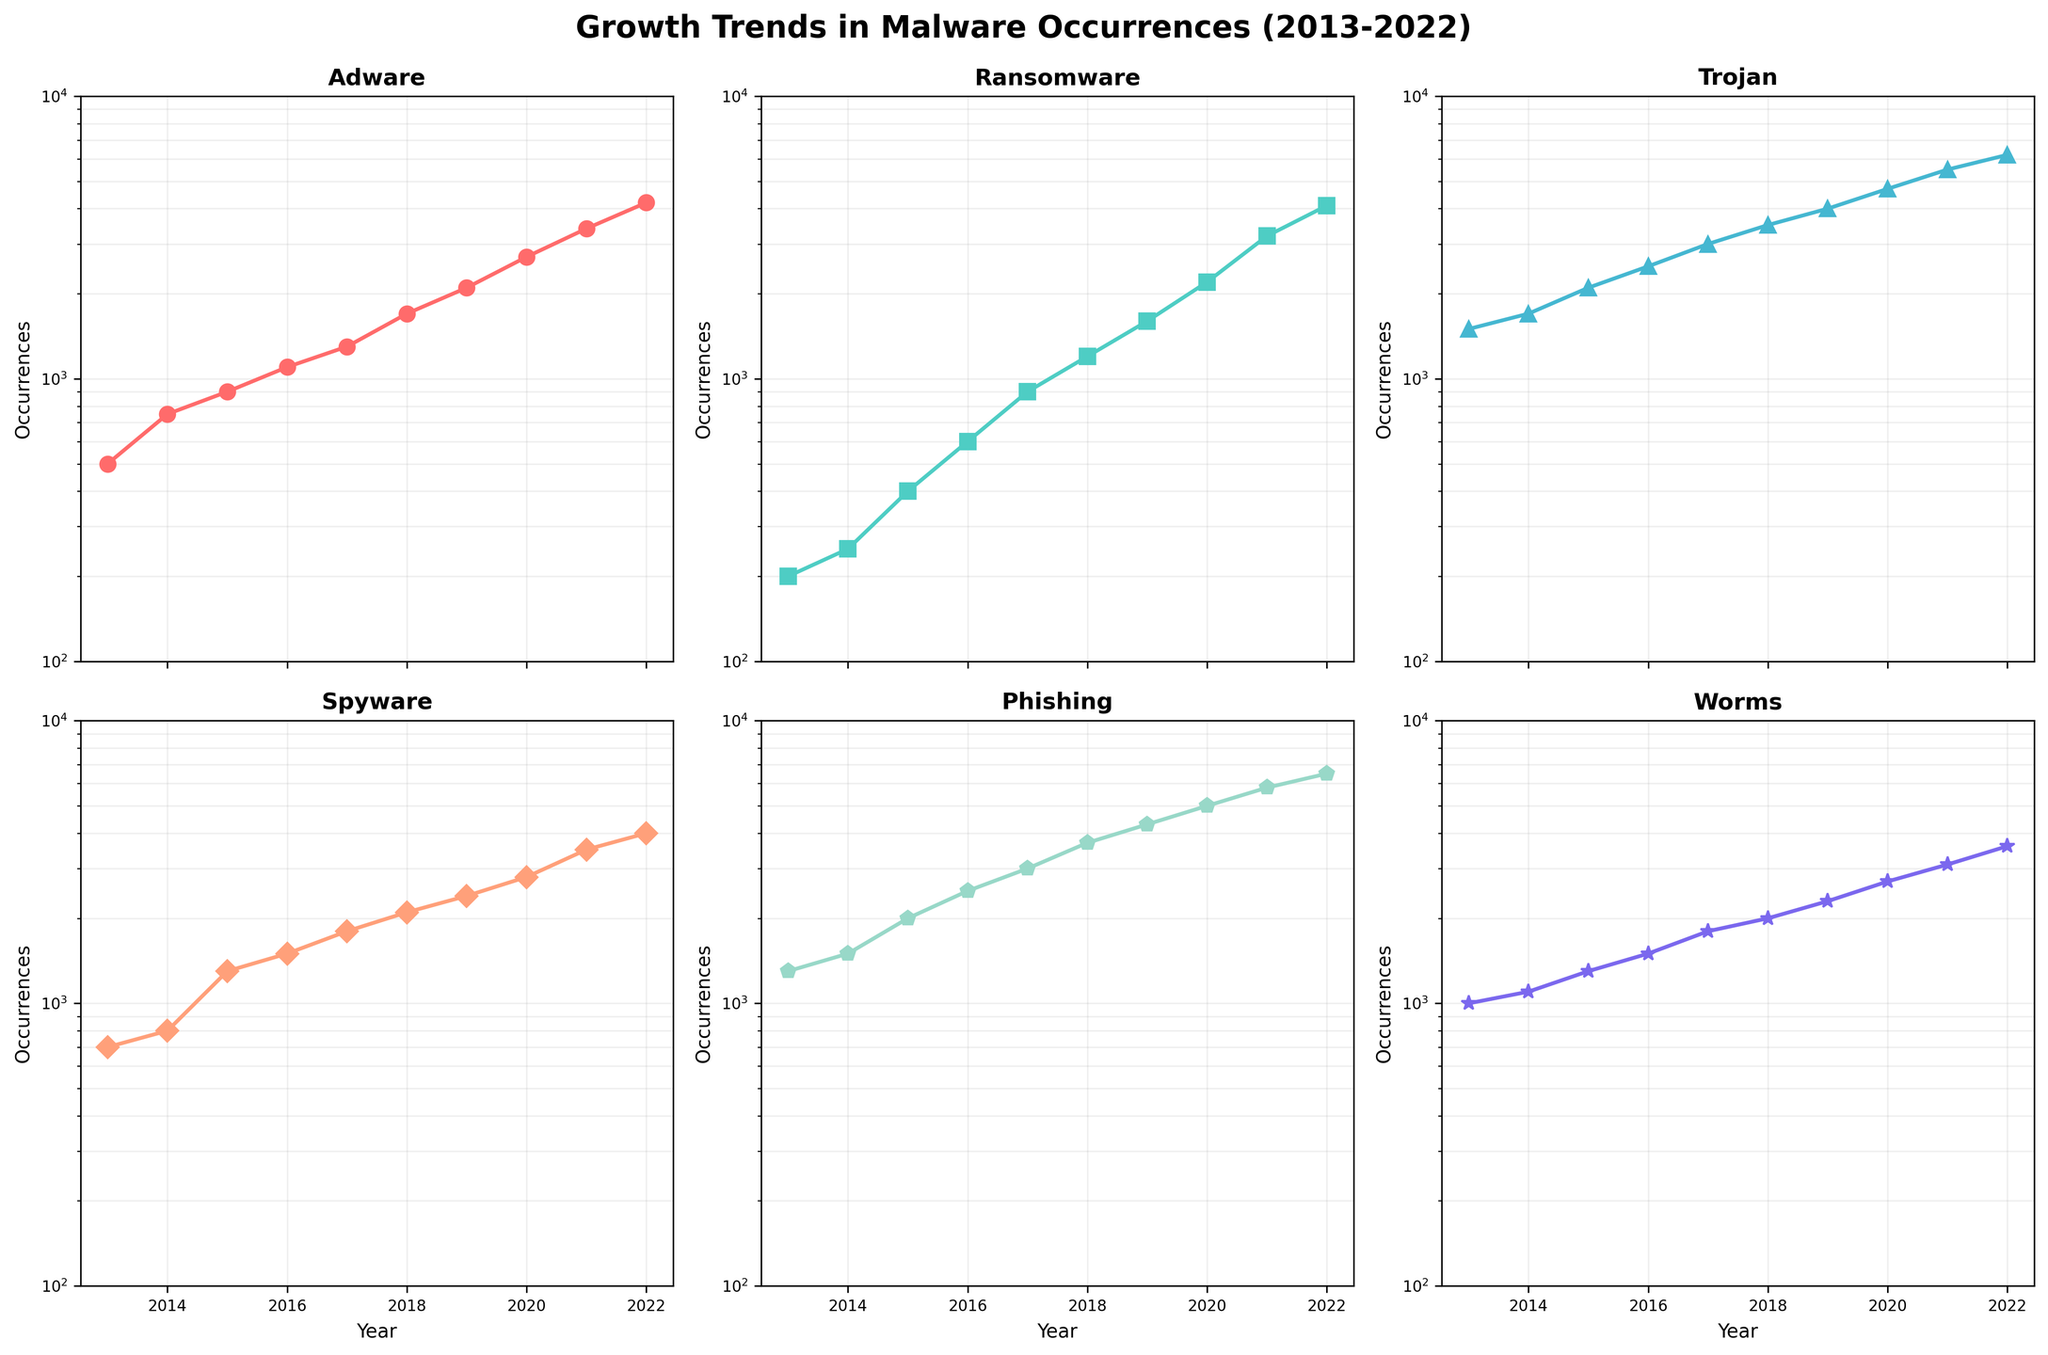Which type of malware had the least occurrences in 2013? By examining the lowest data point in 2013 across all subplots, we find that Ransomware had the smallest occurrences with 200.
Answer: Ransomware What is the overall trend of Phishing occurrences from 2013 to 2022? By analyzing the subplot for Phishing, we can see a consistent increase in occurrences over the years, indicating an upward trend.
Answer: Increasing How many years did Trojan have more than 4000 occurrences? By locating the data points for Trojan and counting the number of years with values above 4000, we see it happened in 3 years (2019, 2021, 2022).
Answer: 3 years Which malware had the largest growth between 2013 and 2022? Calculating the difference between 2022 and 2013 for each malware type, we see that Phishing grew the most (6500-1300=5200).
Answer: Phishing What is the rate of increase for Adware from 2016 to 2017? The Adware data points are 1100 (2016) and 1300 (2017). The rate of increase = \((1300 - 1100) / 1100 \cdot 100\% = 18.18\%\).
Answer: 18.18% Which type of malware had the most occurrences in 2020? Comparing the 2020 data points, Phishing had the highest occurrences with 5000.
Answer: Phishing Did any type of malware have an exponential growth pattern? Observing the log-scale subplots, the growth patterns of all malware types appear relatively linear on a log scale, indicating exponential growth.
Answer: Yes Between Spyware and Worms, which had fewer occurrences in 2018? By checking the 2018 data points, we see that Worms had 2000 occurrences, whereas Spyware had 2100 occurrences.
Answer: Worms What's the approximate average number of Ransomware occurrences over the decade? Adding the Ransomware data from 2013 to 2022 (200 + 250 + 400 + 600 + 900 + 1200 + 1600 + 2200 + 3200 + 4100 = 14650) and dividing by 10 yields an average of 1465.
Answer: 1465 Which malware type had the second lowest occurrences in 2022? Listing the 2022 occurrences (Adware: 4200, Ransomware: 4100, Trojan: 6200, Spyware: 4000, Phishing: 6500, Worms: 3600), the second lowest is Spyware with 4000.
Answer: Spyware 